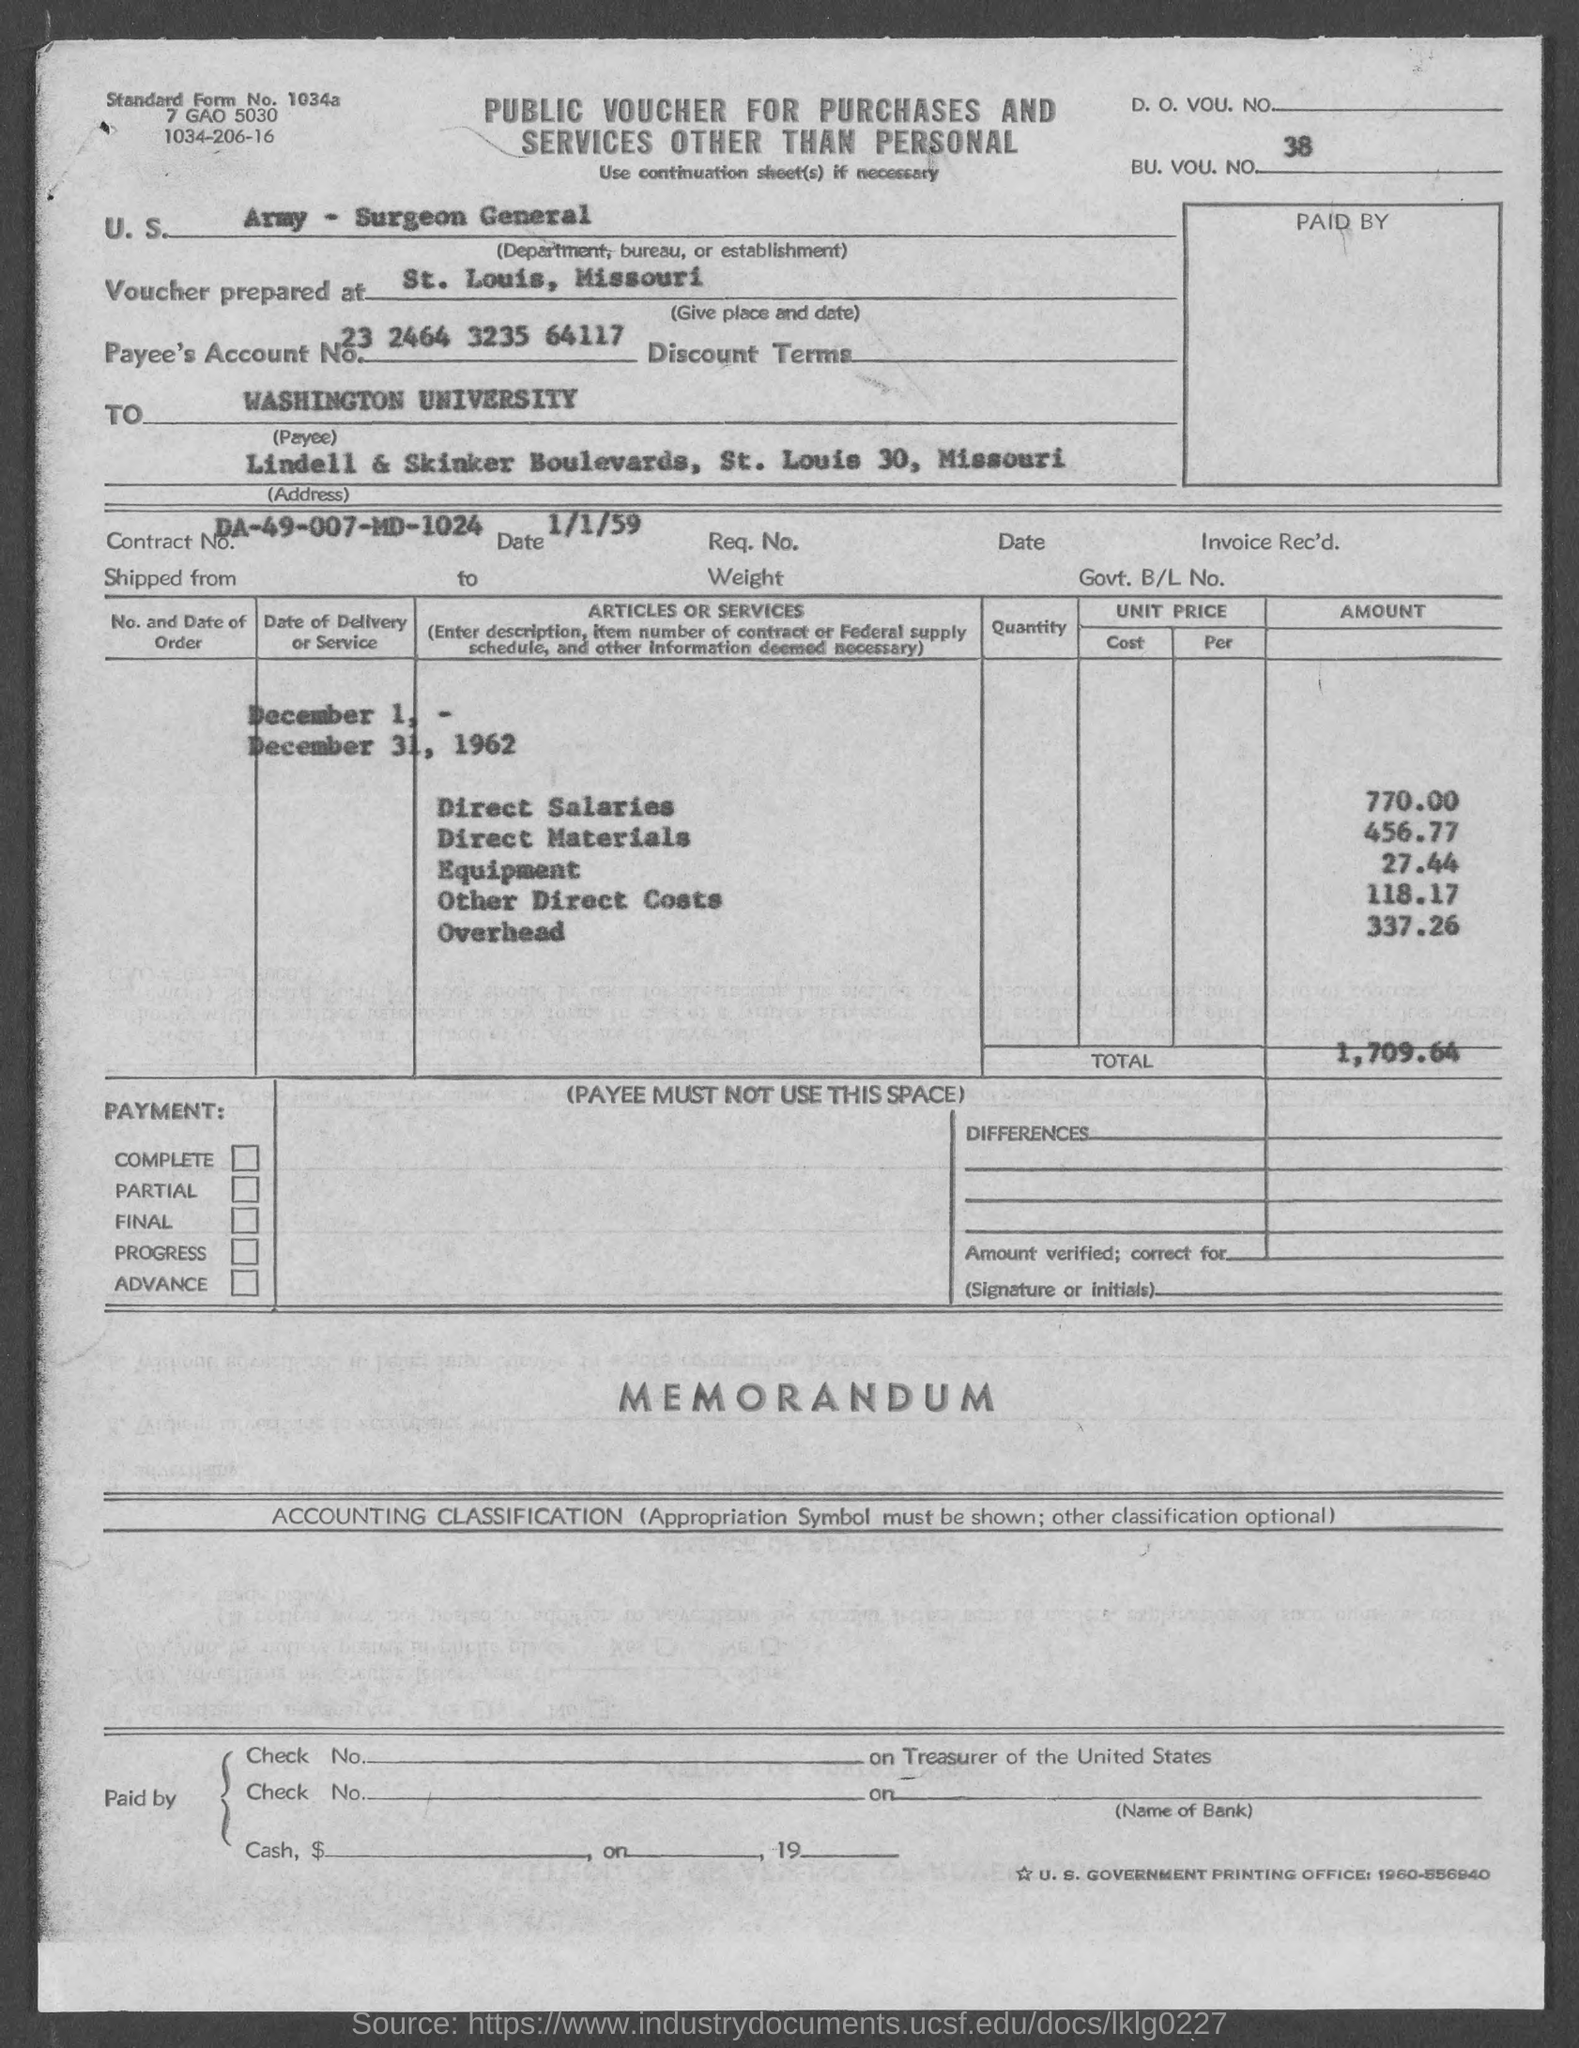What is the bu. vou. no.?
Provide a short and direct response. 38. What is the standard form no.?
Give a very brief answer. 1034a. What is the payee's account no.?
Offer a very short reply. 23 2464 3235 64117. What is the contract no.?
Provide a short and direct response. DA-49-007-MD-1024. What is the total ?
Your response must be concise. 1,709.64. What is the amount of direct salaries?
Provide a short and direct response. 770.00. What is the amount of direct materials ?
Give a very brief answer. 456.77. What is the amount of equipment ?
Ensure brevity in your answer.  27 44. What is the amount of other direct costs?
Offer a terse response. 118.17. What is the amount of overhead ?
Your answer should be compact. 337 26. 